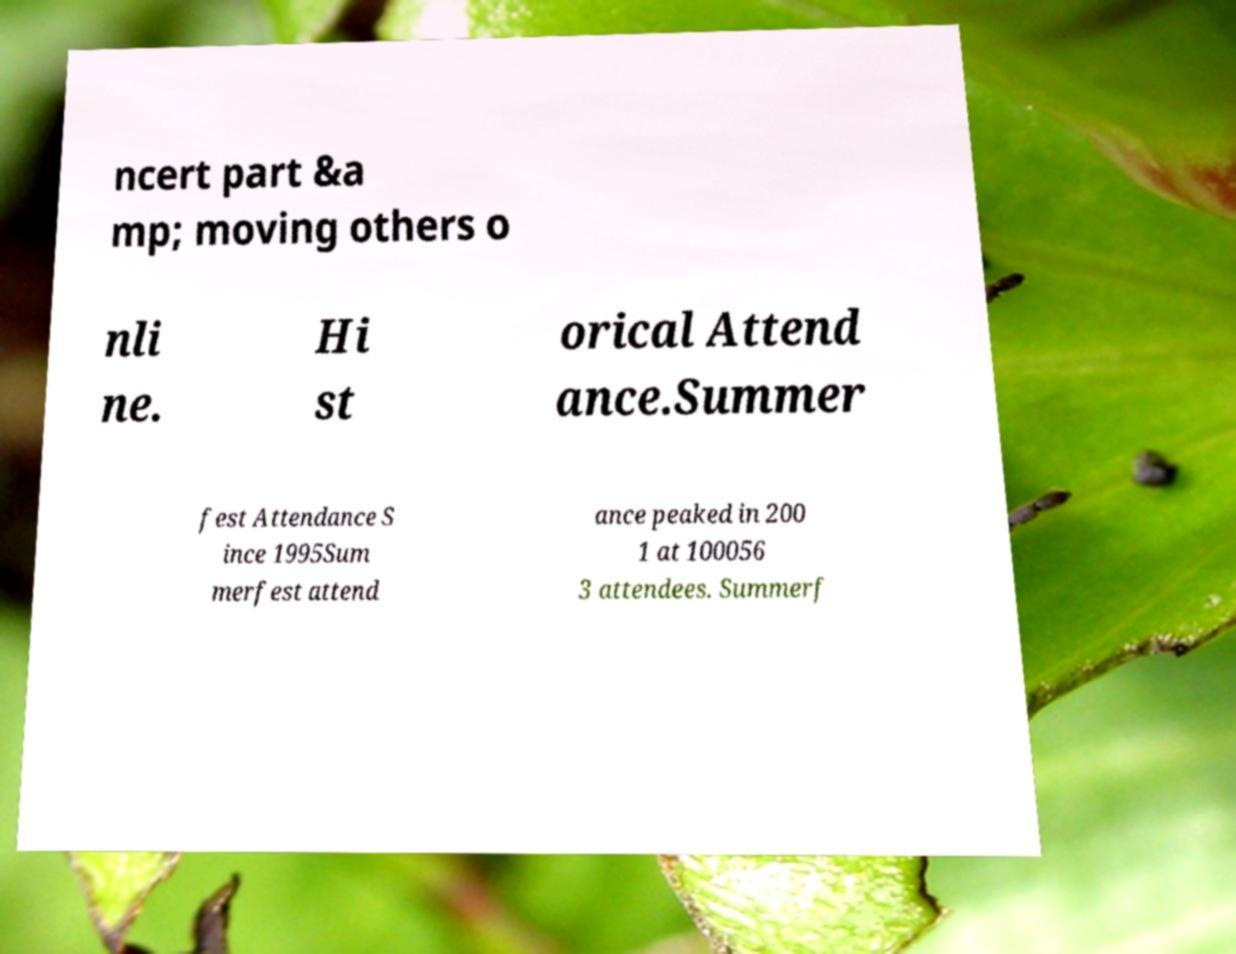Please identify and transcribe the text found in this image. ncert part &a mp; moving others o nli ne. Hi st orical Attend ance.Summer fest Attendance S ince 1995Sum merfest attend ance peaked in 200 1 at 100056 3 attendees. Summerf 